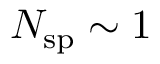<formula> <loc_0><loc_0><loc_500><loc_500>N _ { s p } \sim 1</formula> 